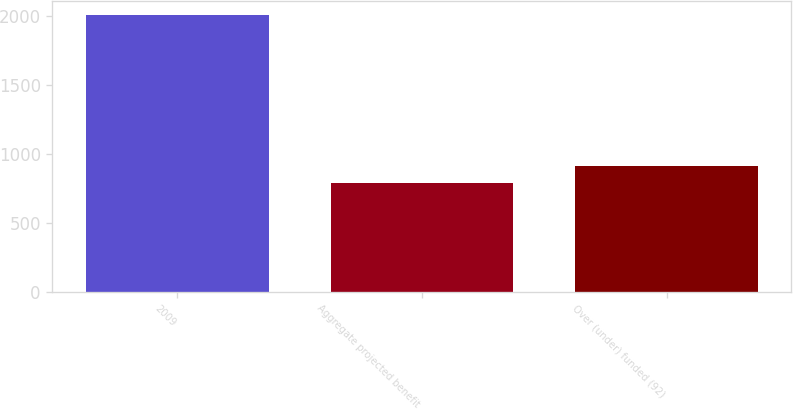Convert chart. <chart><loc_0><loc_0><loc_500><loc_500><bar_chart><fcel>2009<fcel>Aggregate projected benefit<fcel>Over (under) funded (92)<nl><fcel>2009<fcel>787<fcel>909.2<nl></chart> 